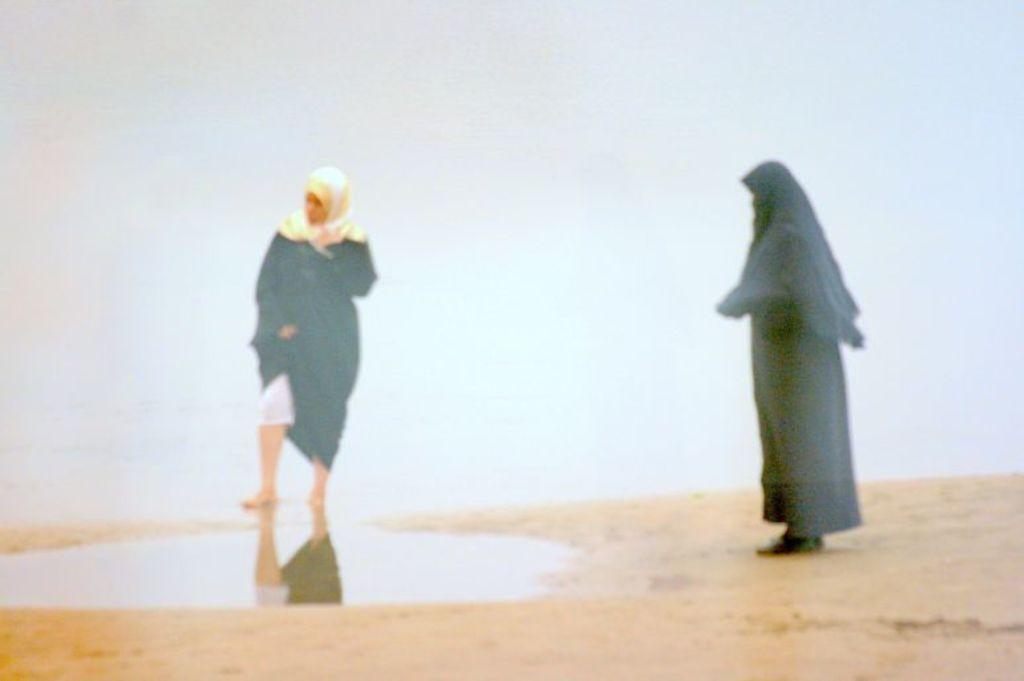How would you summarize this image in a sentence or two? In this image there are two women, there is sand towards the bottom of the image, the background of the image is white in color. 